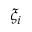Convert formula to latex. <formula><loc_0><loc_0><loc_500><loc_500>\xi _ { i }</formula> 